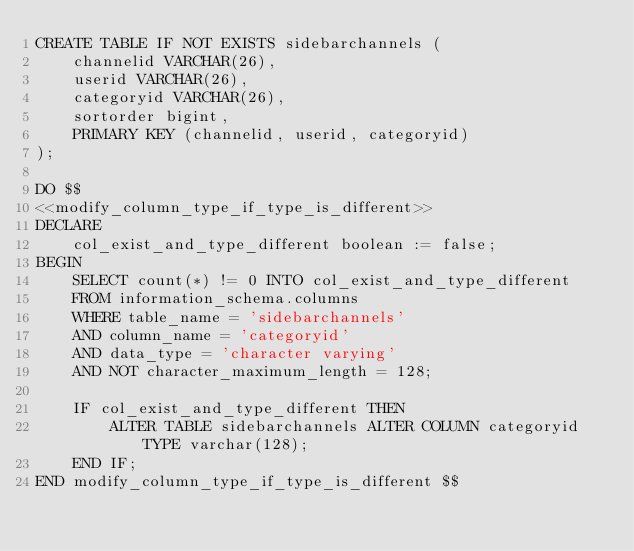Convert code to text. <code><loc_0><loc_0><loc_500><loc_500><_SQL_>CREATE TABLE IF NOT EXISTS sidebarchannels (
    channelid VARCHAR(26),
    userid VARCHAR(26),
    categoryid VARCHAR(26),
    sortorder bigint,
    PRIMARY KEY (channelid, userid, categoryid)
);

DO $$
<<modify_column_type_if_type_is_different>>
DECLARE
    col_exist_and_type_different boolean := false;
BEGIN
    SELECT count(*) != 0 INTO col_exist_and_type_different
    FROM information_schema.columns
    WHERE table_name = 'sidebarchannels'
    AND column_name = 'categoryid'
    AND data_type = 'character varying'
    AND NOT character_maximum_length = 128;

    IF col_exist_and_type_different THEN
        ALTER TABLE sidebarchannels ALTER COLUMN categoryid TYPE varchar(128);
    END IF;
END modify_column_type_if_type_is_different $$
</code> 